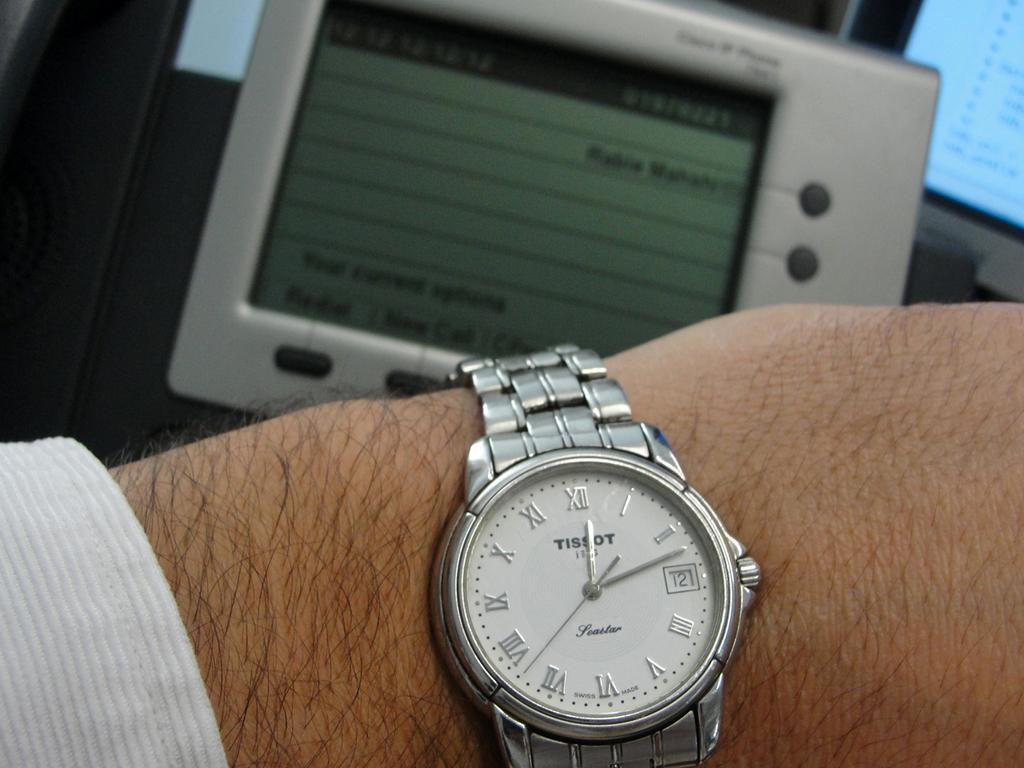Provide a one-sentence caption for the provided image. A mam wearing a silver with white dial Tissot wrist watch. 